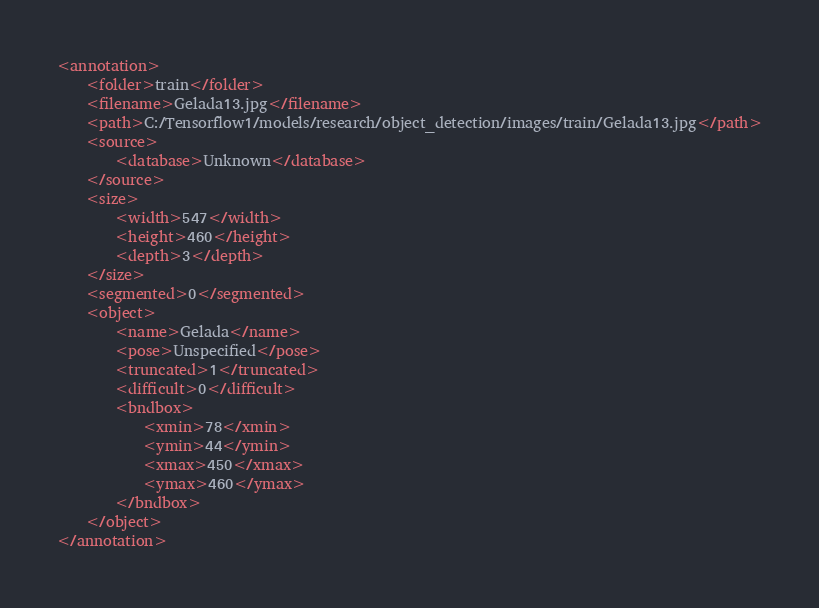<code> <loc_0><loc_0><loc_500><loc_500><_XML_><annotation>
	<folder>train</folder>
	<filename>Gelada13.jpg</filename>
	<path>C:/Tensorflow1/models/research/object_detection/images/train/Gelada13.jpg</path>
	<source>
		<database>Unknown</database>
	</source>
	<size>
		<width>547</width>
		<height>460</height>
		<depth>3</depth>
	</size>
	<segmented>0</segmented>
	<object>
		<name>Gelada</name>
		<pose>Unspecified</pose>
		<truncated>1</truncated>
		<difficult>0</difficult>
		<bndbox>
			<xmin>78</xmin>
			<ymin>44</ymin>
			<xmax>450</xmax>
			<ymax>460</ymax>
		</bndbox>
	</object>
</annotation>
</code> 